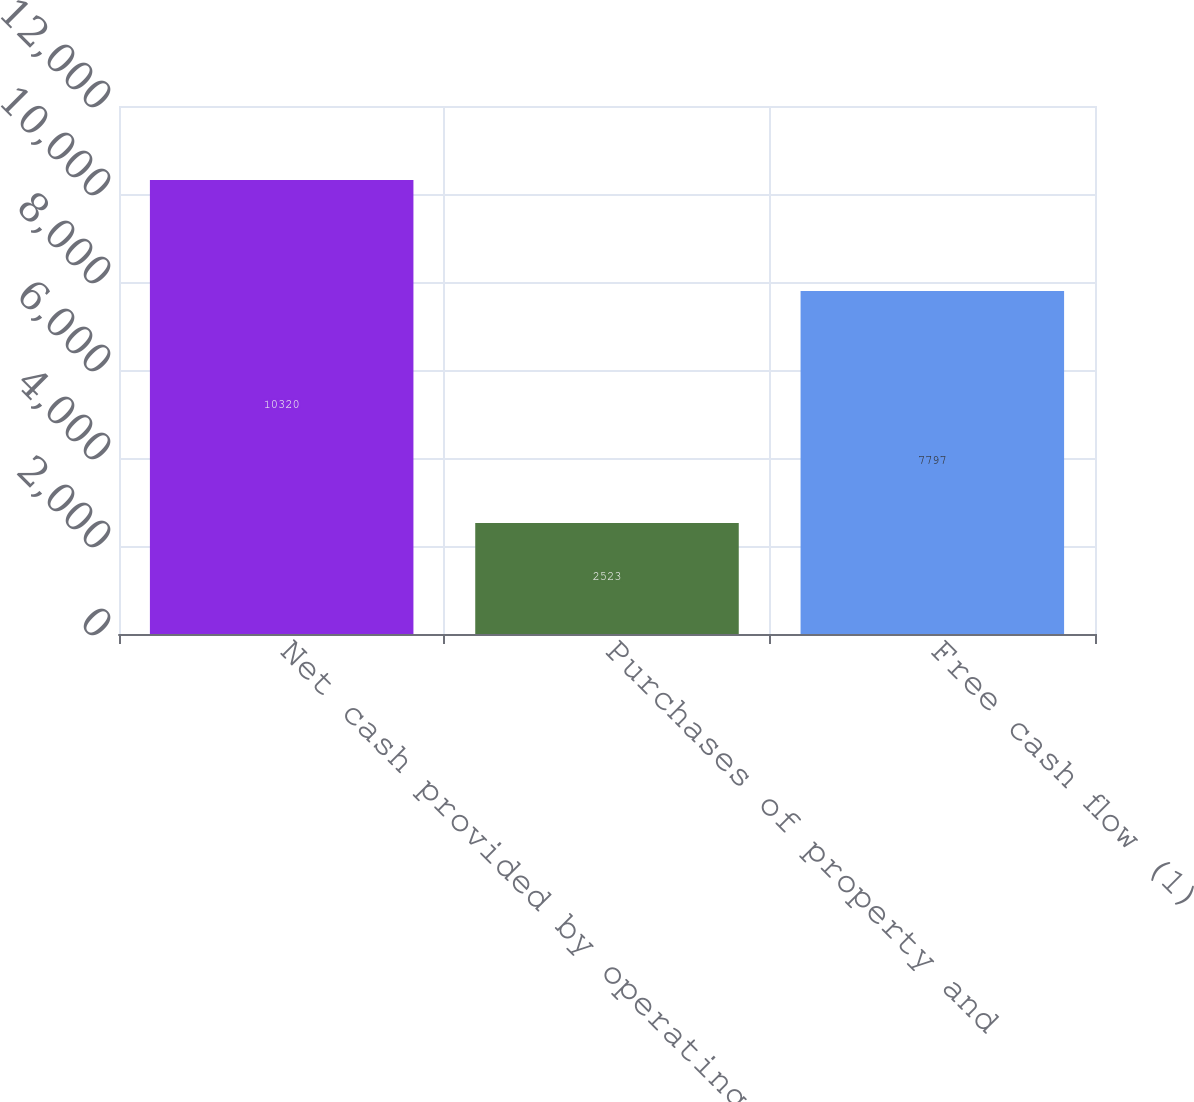<chart> <loc_0><loc_0><loc_500><loc_500><bar_chart><fcel>Net cash provided by operating<fcel>Purchases of property and<fcel>Free cash flow (1)<nl><fcel>10320<fcel>2523<fcel>7797<nl></chart> 